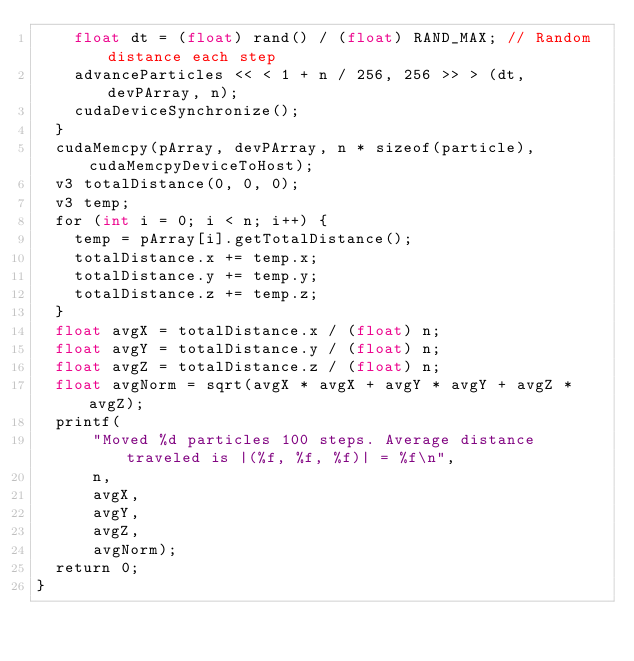<code> <loc_0><loc_0><loc_500><loc_500><_Cuda_>    float dt = (float) rand() / (float) RAND_MAX; // Random distance each step
    advanceParticles << < 1 + n / 256, 256 >> > (dt, devPArray, n);
    cudaDeviceSynchronize();
  }
  cudaMemcpy(pArray, devPArray, n * sizeof(particle), cudaMemcpyDeviceToHost);
  v3 totalDistance(0, 0, 0);
  v3 temp;
  for (int i = 0; i < n; i++) {
    temp = pArray[i].getTotalDistance();
    totalDistance.x += temp.x;
    totalDistance.y += temp.y;
    totalDistance.z += temp.z;
  }
  float avgX = totalDistance.x / (float) n;
  float avgY = totalDistance.y / (float) n;
  float avgZ = totalDistance.z / (float) n;
  float avgNorm = sqrt(avgX * avgX + avgY * avgY + avgZ * avgZ);
  printf(
      "Moved %d particles 100 steps. Average distance traveled is |(%f, %f, %f)| = %f\n",
      n,
      avgX,
      avgY,
      avgZ,
      avgNorm);
  return 0;
}</code> 